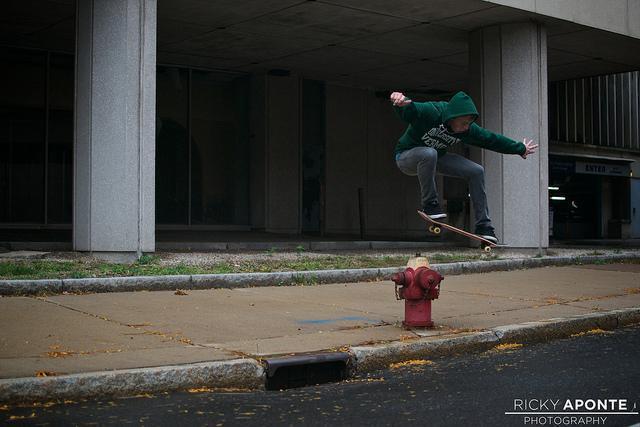Who probably took the picture?
Select the accurate answer and provide explanation: 'Answer: answer
Rationale: rationale.'
Options: Ricky aponte, trump, skateboarder, steve jobs. Answer: ricky aponte.
Rationale: The name of the photography company is written in the lower right corner of the image. 